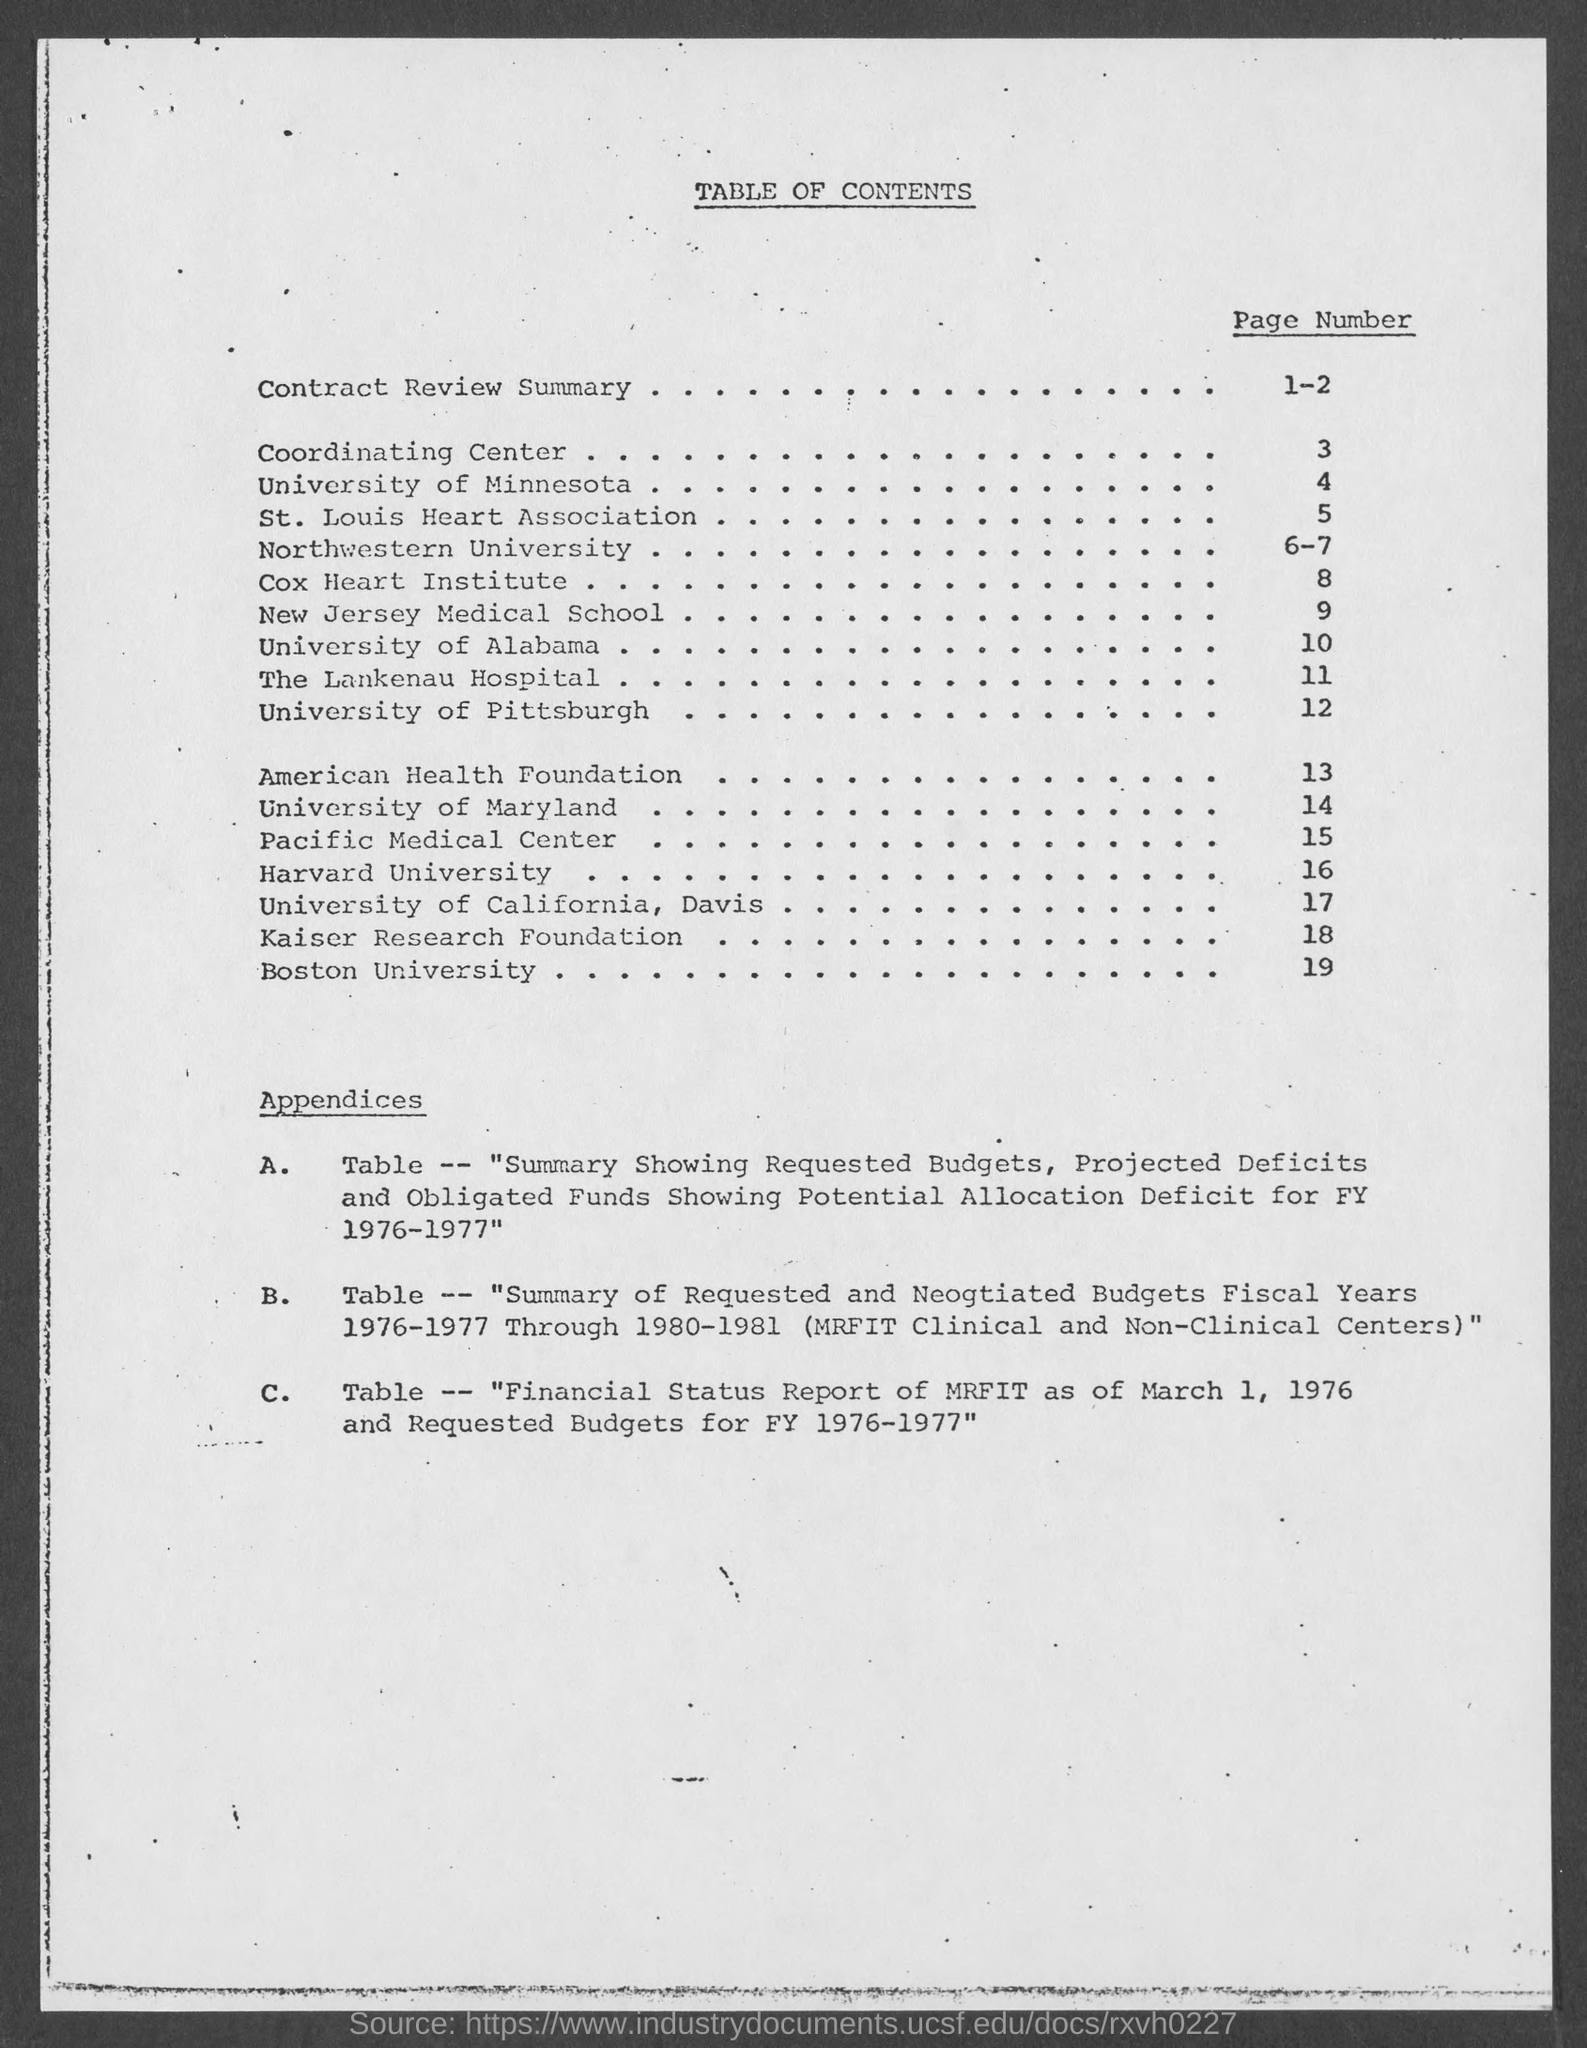Mention a couple of crucial points in this snapshot. The page number of the Contract Review Summary is 1-2. The title of the document is [insert title], and it contains a table of contents [insert page numbers]. 